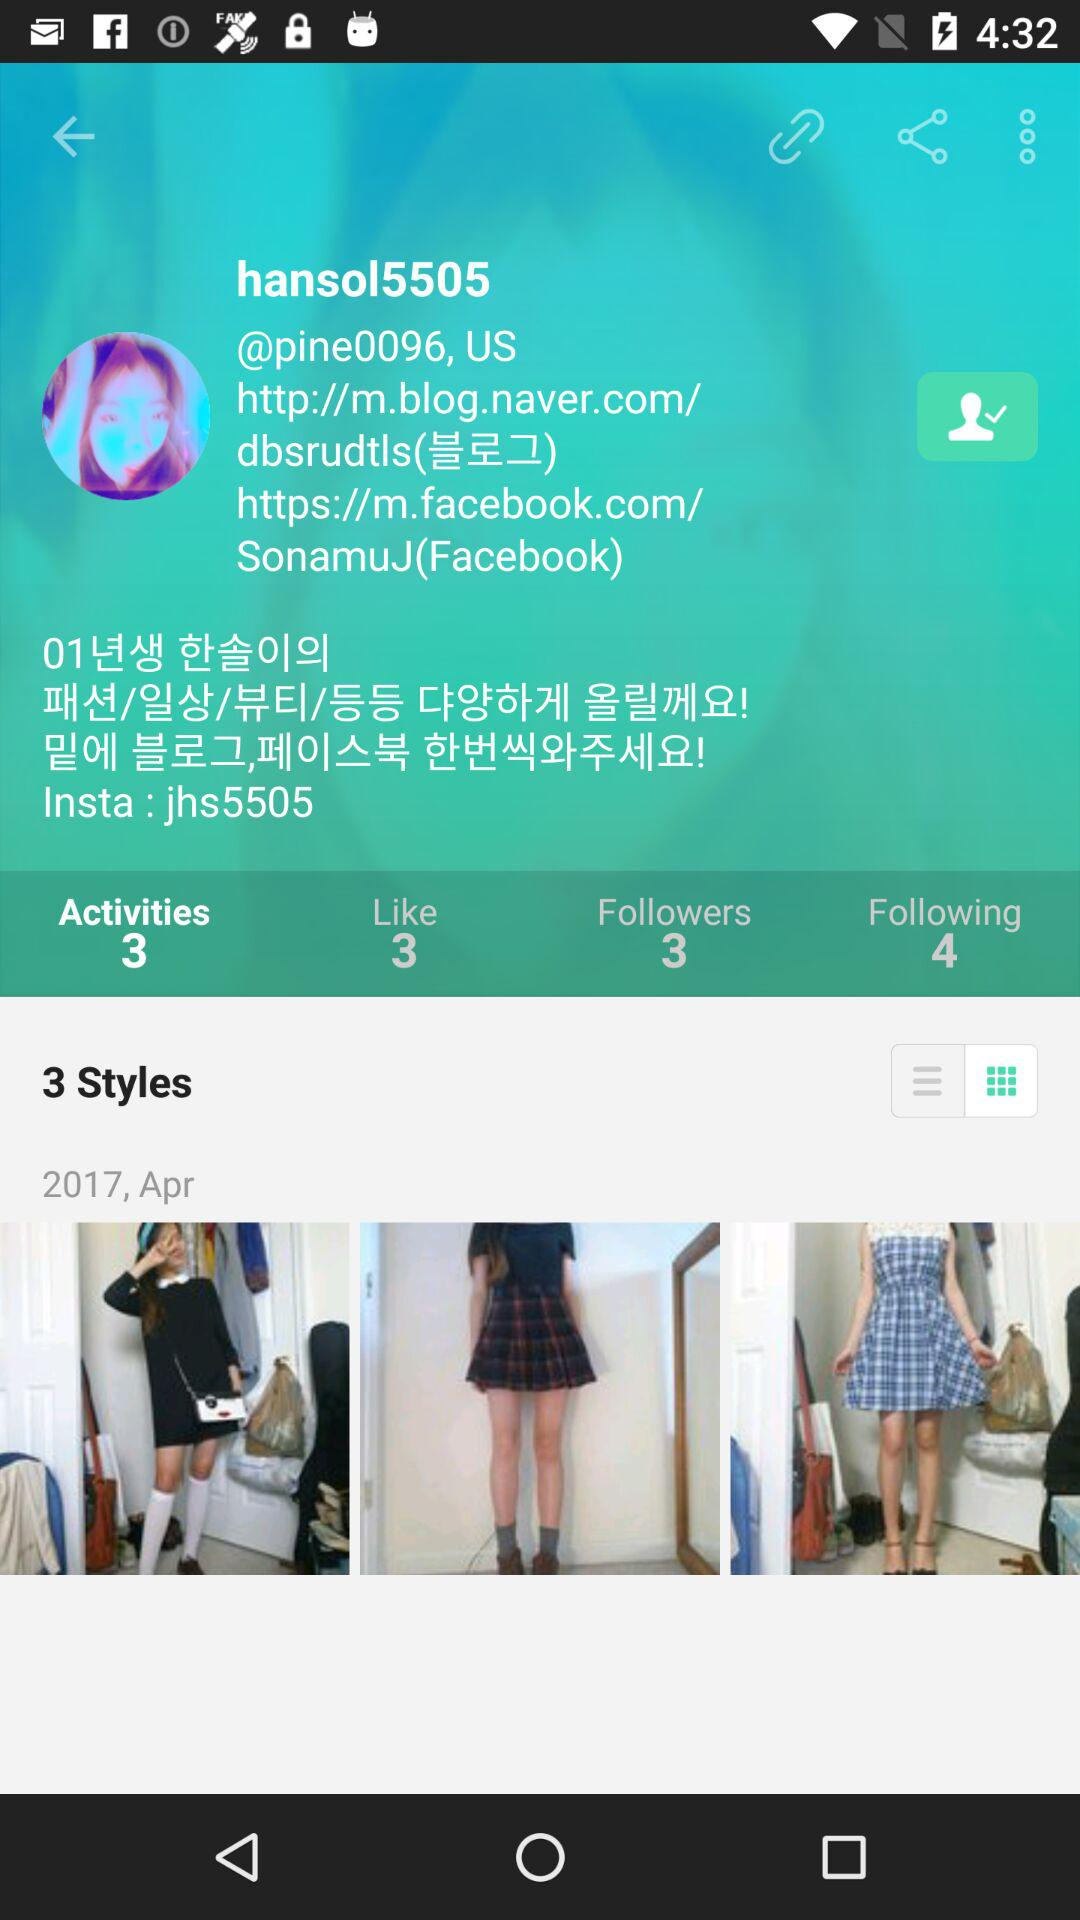How many styles are there? There are 3 styles. 